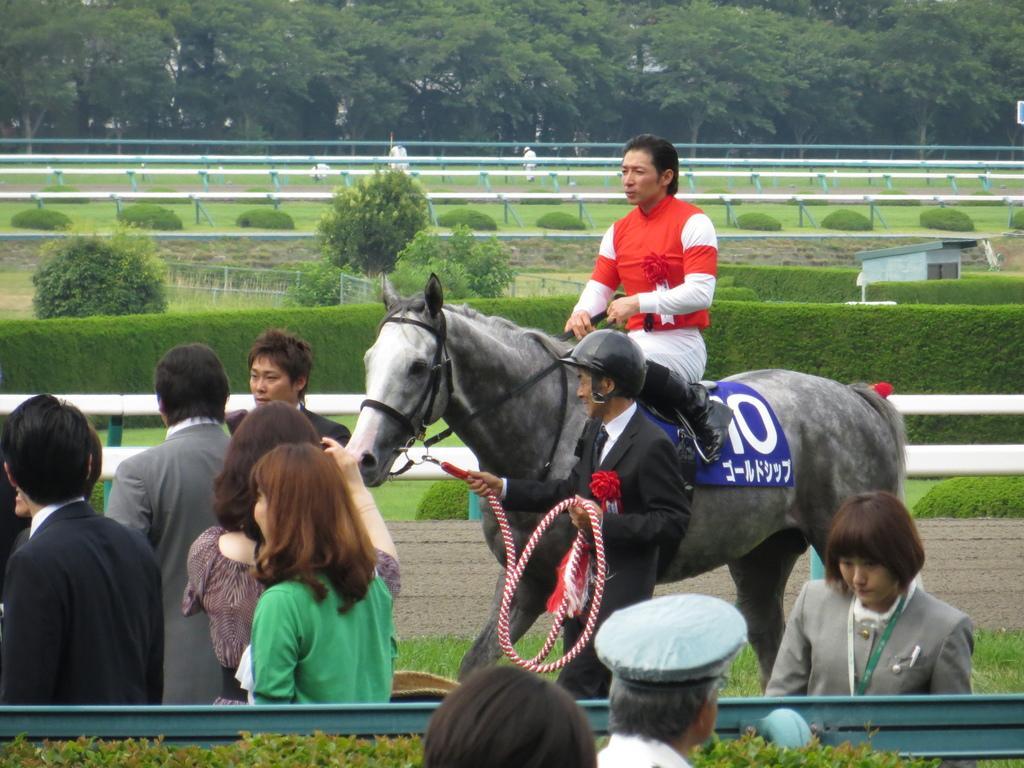Describe this image in one or two sentences. The picture was clicked on a race course , with a guy riding the horse and another guy who is catching the horse. We observe people standing and viewing the horse. In the background we find many trees. 